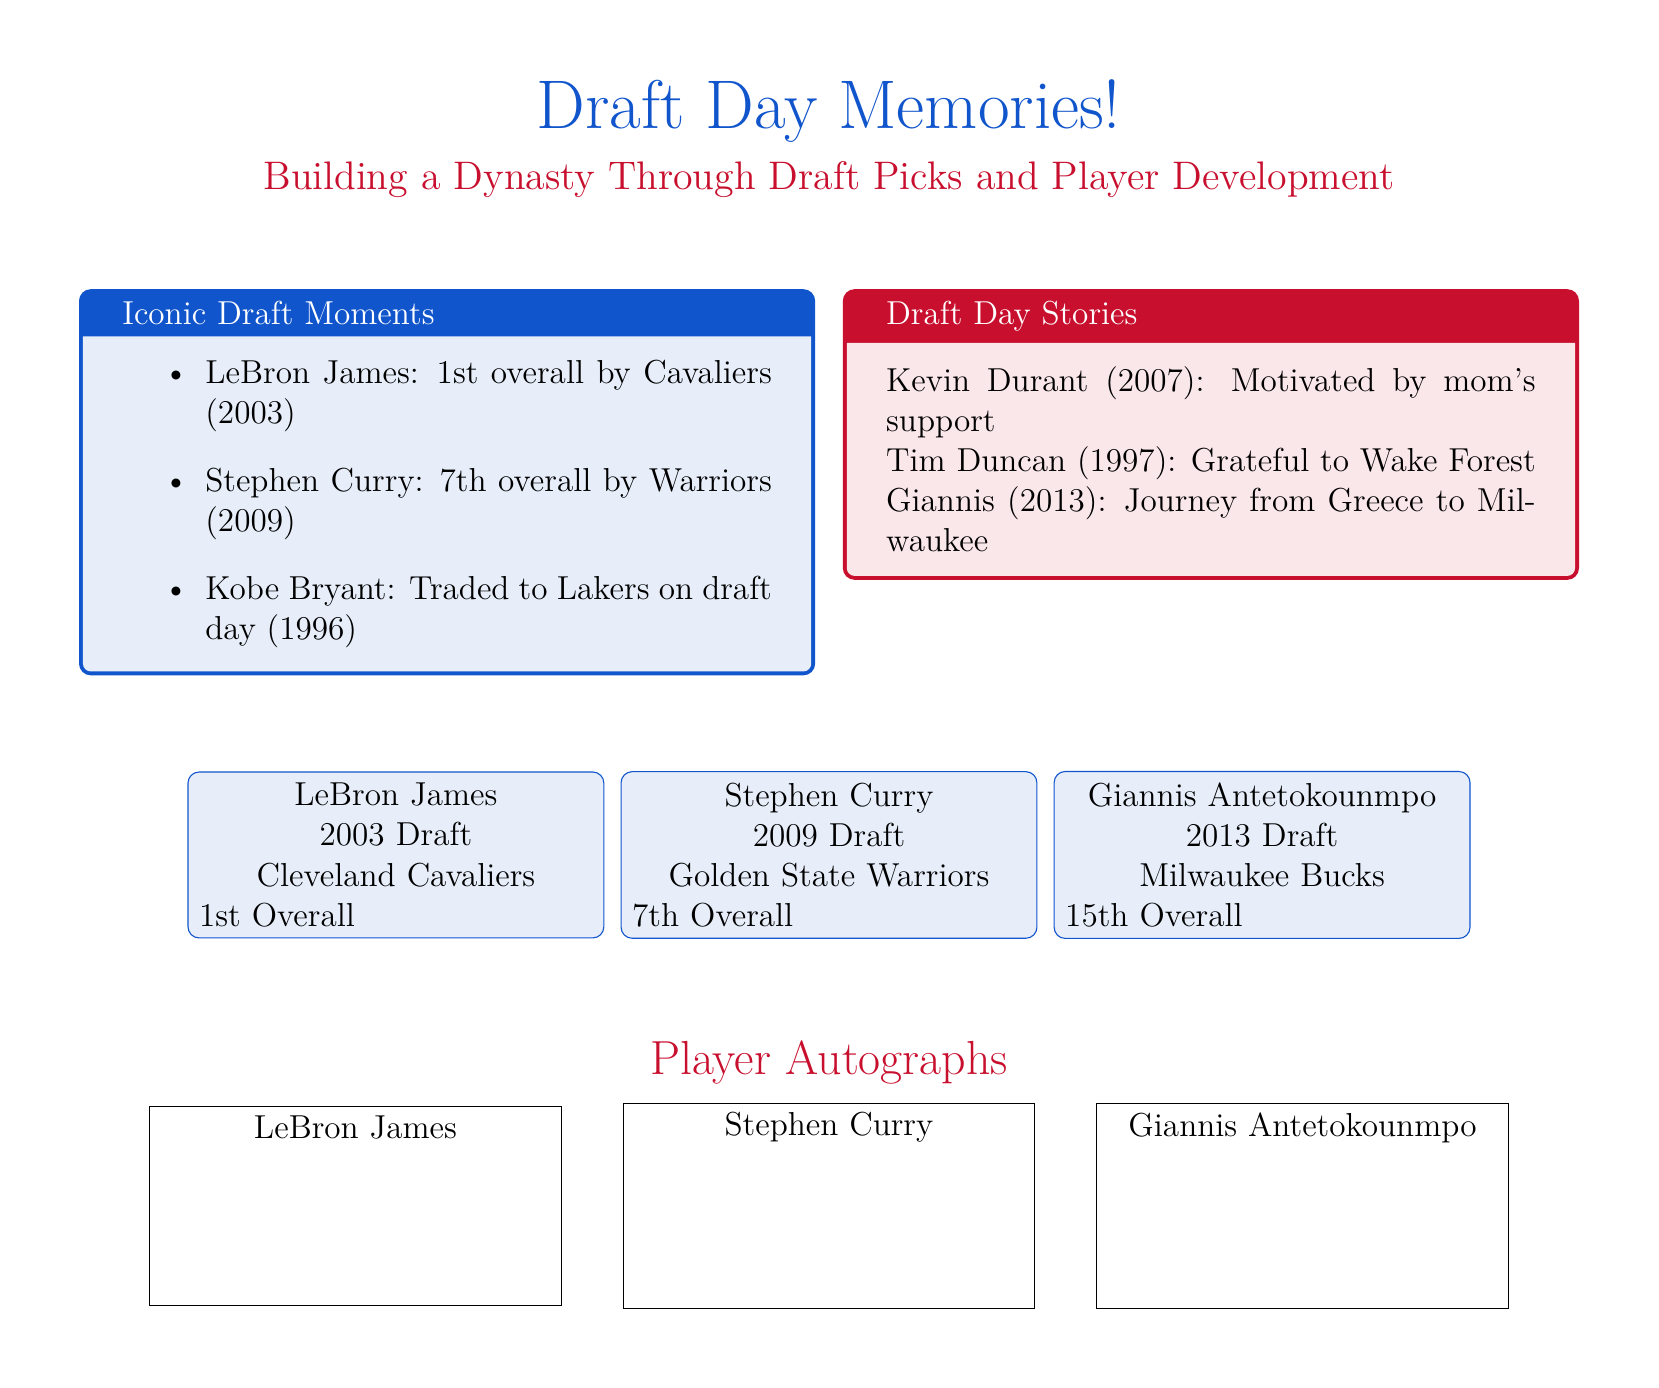What year was LeBron James drafted? LeBron James is listed under the 2003 Draft section in the document, indicating the year he was drafted.
Answer: 2003 What team drafted Stephen Curry? Stephen Curry is indicated to have been drafted by the Golden State Warriors in the document.
Answer: Golden State Warriors Who was the first overall pick in the 2003 Draft? The document specifies LeBron James as the 1st Overall pick in the 2003 Draft.
Answer: LeBron James What is the main theme of the greeting card? The greeting card's main theme is highlighted in the title, which mentions building a dynasty through draft picks and player development.
Answer: Building a Dynasty Through Draft Picks and Player Development How many iconic draft moments are listed? The document features a list under "Iconic Draft Moments," which includes three moments.
Answer: 3 What draft position was Giannis Antetokounmpo selected? The document states that Giannis was the 15th Overall pick in the 2013 Draft.
Answer: 15th Overall What notable story is associated with Kevin Durant? The draft day story associated with Kevin Durant mentions that it was motivated by his mom's support.
Answer: Motivated by mom's support Which player was traded on draft day in 1996? The document indicates that Kobe Bryant was traded to the Lakers on draft day in 1996.
Answer: Kobe Bryant What color theme is used for the document? The color theme is indicated by using colors like nba_blue and nba_red throughout the document.
Answer: nba_blue and nba_red 